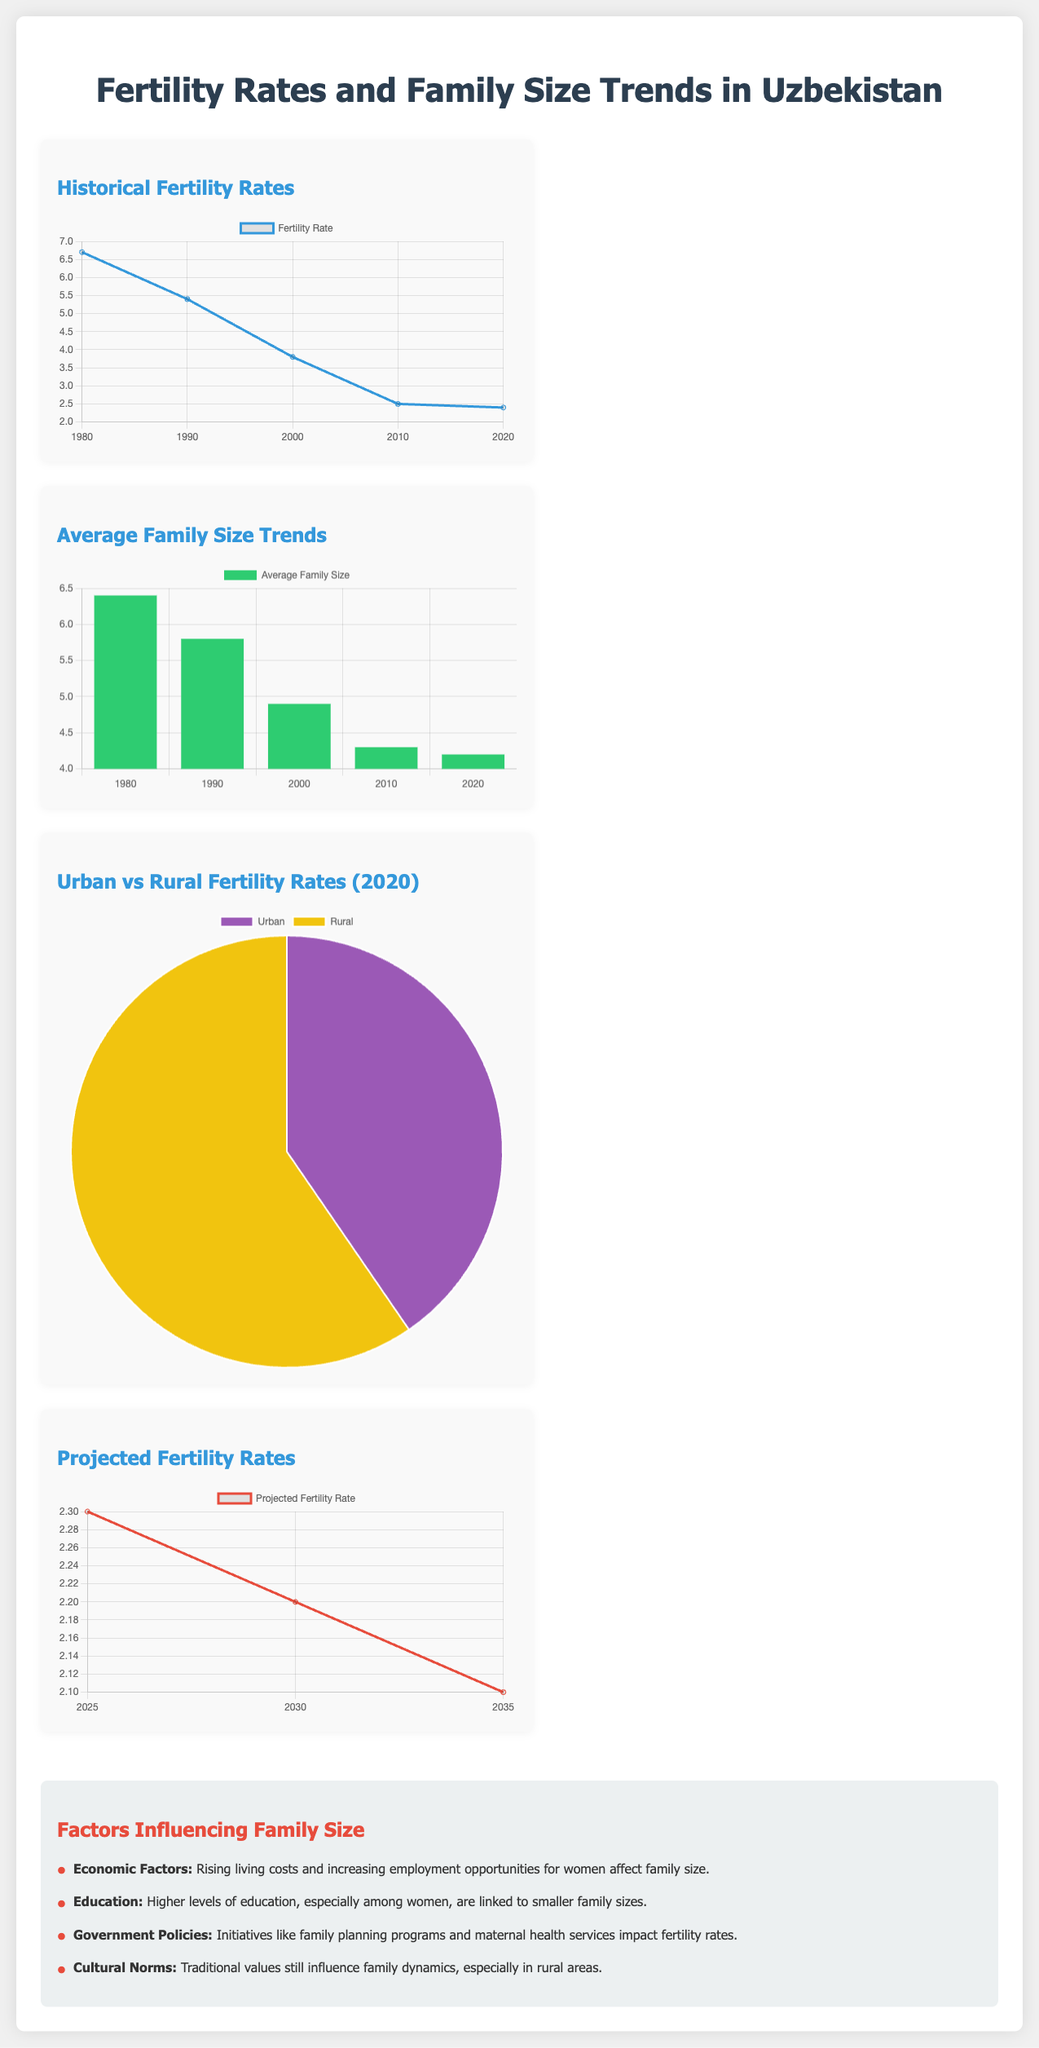what was the fertility rate in 2020? The fertility rate in 2020 is shown as the data point on the chart labeled '2020', which is 2.4.
Answer: 2.4 what was the average family size in 1990? The average family size in 1990 is represented on the bar chart labeled '1990', which indicates 5.8.
Answer: 5.8 which has a higher fertility rate in 2020, urban or rural areas? The pie chart differentiates urban and rural fertility rates in 2020, showing rural rates at 2.8 and urban at 1.9.
Answer: rural what is the projected fertility rate for 2035? The projected fertility rates line chart indicates the value for 2035, which is 2.1.
Answer: 2.1 how did the fertility rate change from 1980 to 2010? The line chart demonstrates a decrease in fertility from 6.7 in 1980 to 2.5 in 2010.
Answer: decrease what economic factor affects family size? The document mentions that rising living costs and increasing employment opportunities for women affect family size.
Answer: rising living costs what color represents average family size in the bar chart? The bar chart uses green to represent average family size data.
Answer: green what is the trend of average family size from 1980 to 2020? The bar chart shows a downward trend in average family size from 6.4 in 1980 to 4.2 in 2020.
Answer: downward what color represents the projected fertility rate in the chart for 2030? For the projected fertility rate chart, the line representing the data is colored red.
Answer: red 